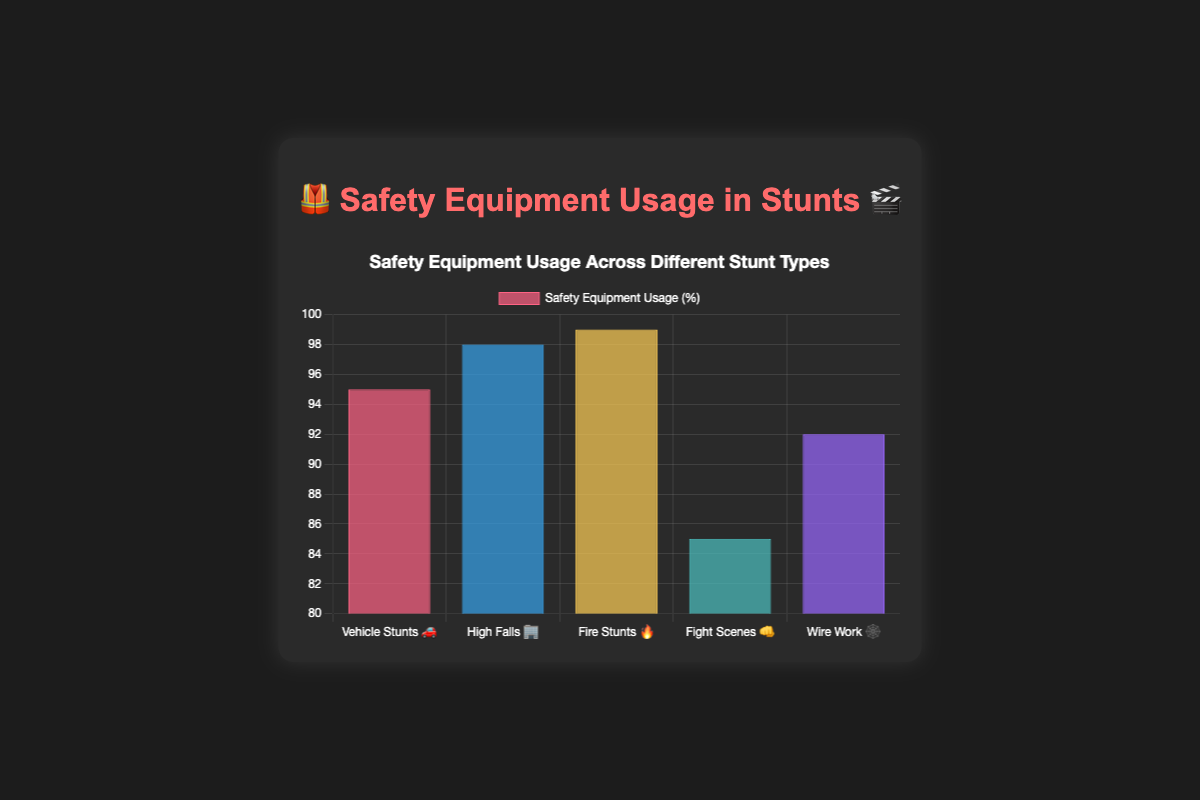What is the title of the figure? The title is displayed in the center at the top of the figure.
Answer: 🦺 Safety Equipment Usage in Stunts 🎬 Which stunt type has the highest safety equipment usage rate? By looking at the bars, the tallest bar represents the highest safety equipment usage.
Answer: Fire Stunts 🔥 What is the safety equipment usage rate for Fight Scenes 👊? Find the corresponding bar and read the value.
Answer: 85% Calculate the difference in safety equipment usage rates between High Falls 🏢 and Wire Work 🕸️. Subtract the rate of Wire Work 🕸️ from High Falls 🏢 (98 - 92).
Answer: 6% How many stunt types have a safety equipment usage rate above 90%? Count the number of bars with values greater than 90%.
Answer: 4 Which stunt type has the lowest safety equipment usage rate, and what is the percentage? Identify the shortest bar and note its value.
Answer: Fight Scenes 👊, 85% Is the safety equipment usage rate for Vehicle Stunts 🚗 greater than for Fight Scenes 👊? Compare the values of the two bars.
Answer: Yes What is the average safety equipment usage rate across all stunt types? Sum the rates and divide by the number of stunt types: (95 + 98 + 99 + 85 + 92) / 5 = 93.8
Answer: 93.8% If the usage rate for Fight Scenes 👊 increased by 10%, what would the new rate be? Add 10 to the current rate of Fight Scenes 👊 (85 + 10).
Answer: 95% Rank the stunt types from highest to lowest safety equipment usage rate. Arrange the values in descending order and list the corresponding stunt types.
Answer: Fire Stunts 🔥, High Falls 🏢, Vehicle Stunts 🚗, Wire Work 🕸️, Fight Scenes 👊 